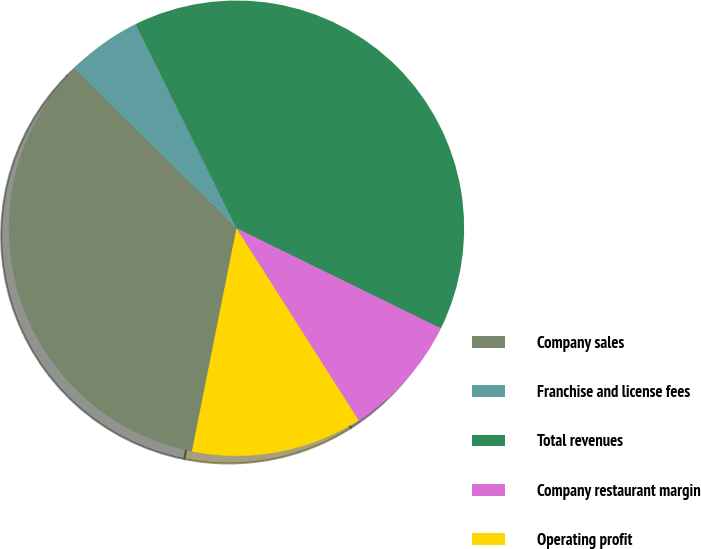<chart> <loc_0><loc_0><loc_500><loc_500><pie_chart><fcel>Company sales<fcel>Franchise and license fees<fcel>Total revenues<fcel>Company restaurant margin<fcel>Operating profit<nl><fcel>34.26%<fcel>5.3%<fcel>39.56%<fcel>8.73%<fcel>12.15%<nl></chart> 